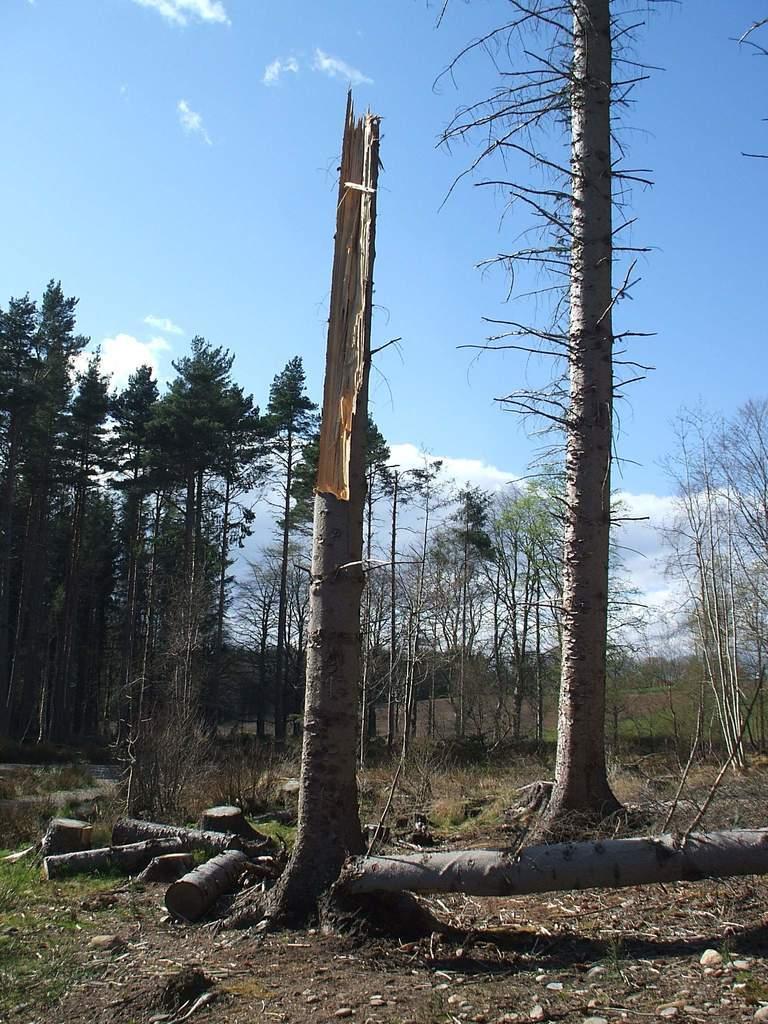Could you give a brief overview of what you see in this image? In this image there is tree trunk , wooden logs, plants, grass, trees, and in the background there is sky. 